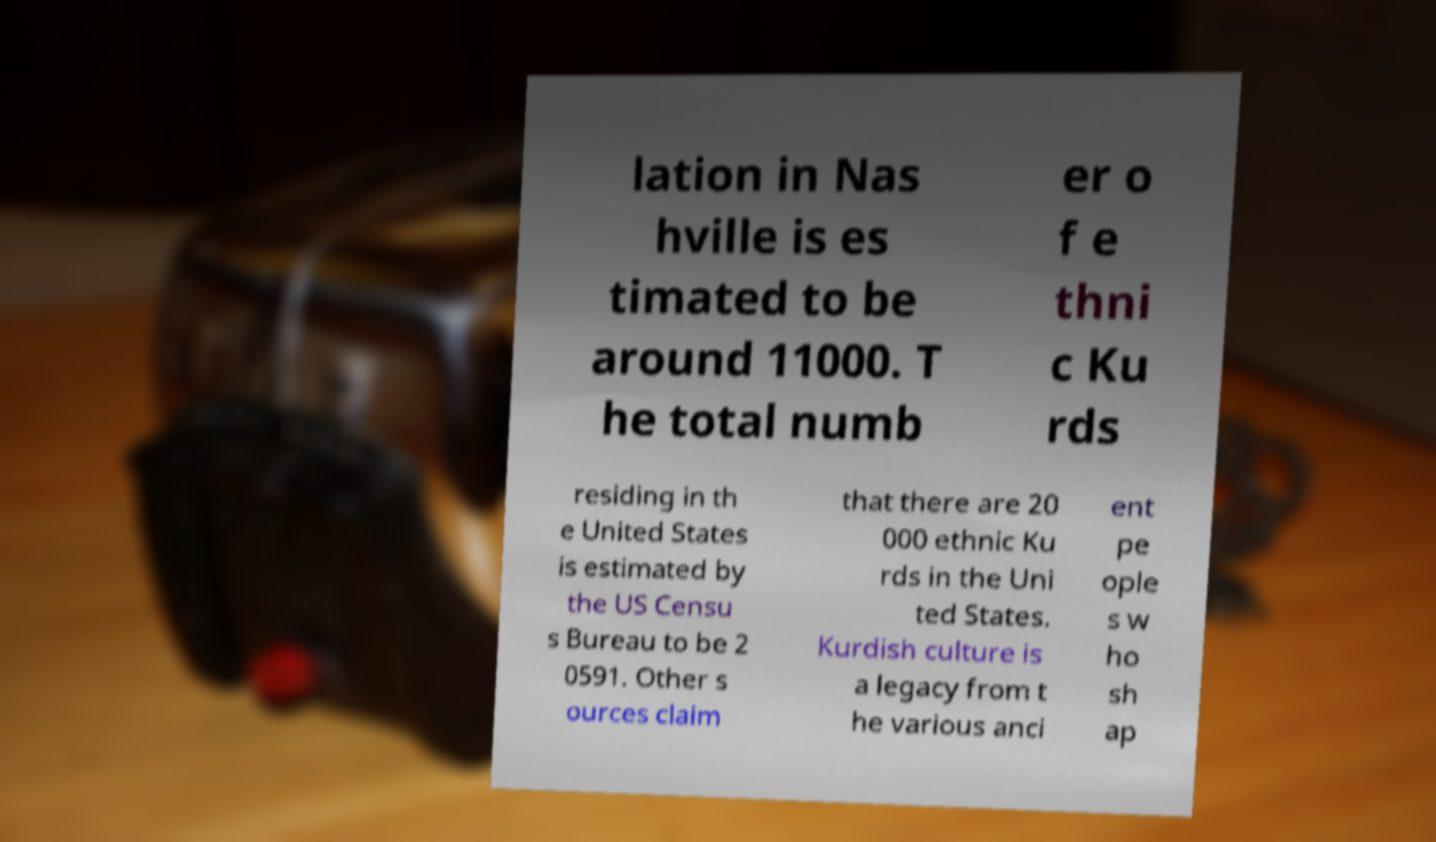There's text embedded in this image that I need extracted. Can you transcribe it verbatim? lation in Nas hville is es timated to be around 11000. T he total numb er o f e thni c Ku rds residing in th e United States is estimated by the US Censu s Bureau to be 2 0591. Other s ources claim that there are 20 000 ethnic Ku rds in the Uni ted States. Kurdish culture is a legacy from t he various anci ent pe ople s w ho sh ap 